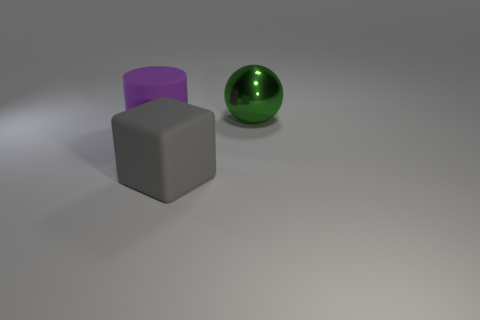Add 2 green things. How many objects exist? 5 Subtract all spheres. How many objects are left? 2 Add 3 matte cylinders. How many matte cylinders are left? 4 Add 2 big gray blocks. How many big gray blocks exist? 3 Subtract 0 brown cubes. How many objects are left? 3 Subtract all balls. Subtract all big blue metal cylinders. How many objects are left? 2 